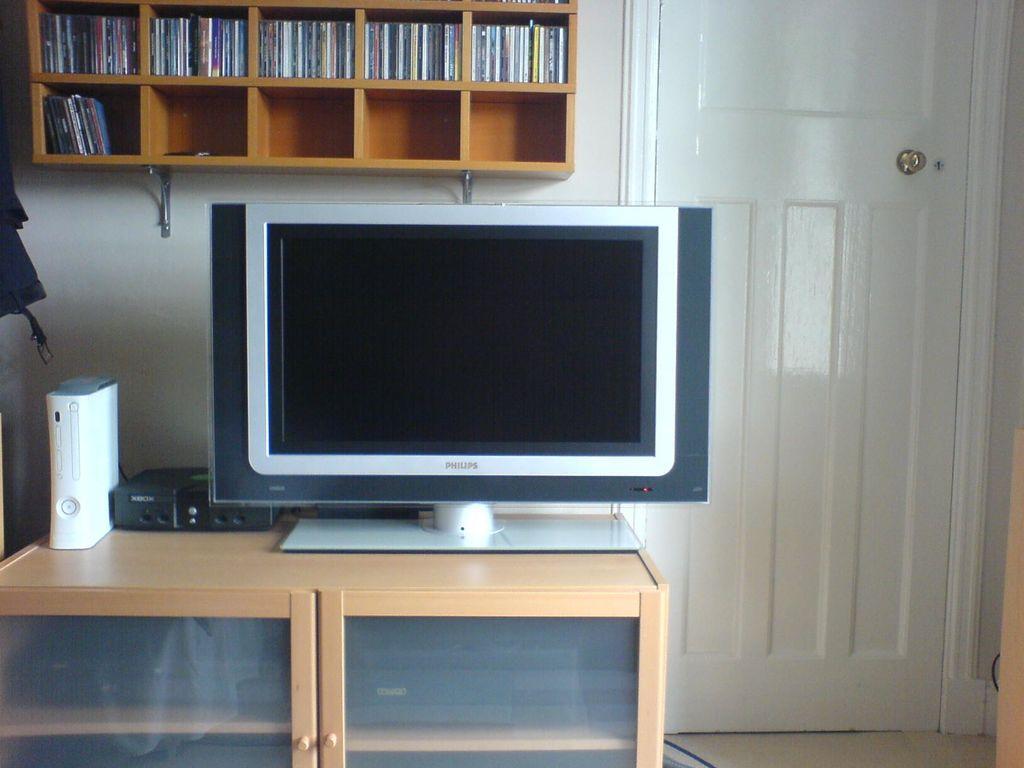Please provide a concise description of this image. In the image we can see a screen, sound box, cupboard, shelves, door, objects on the shelf and this is a floor. 